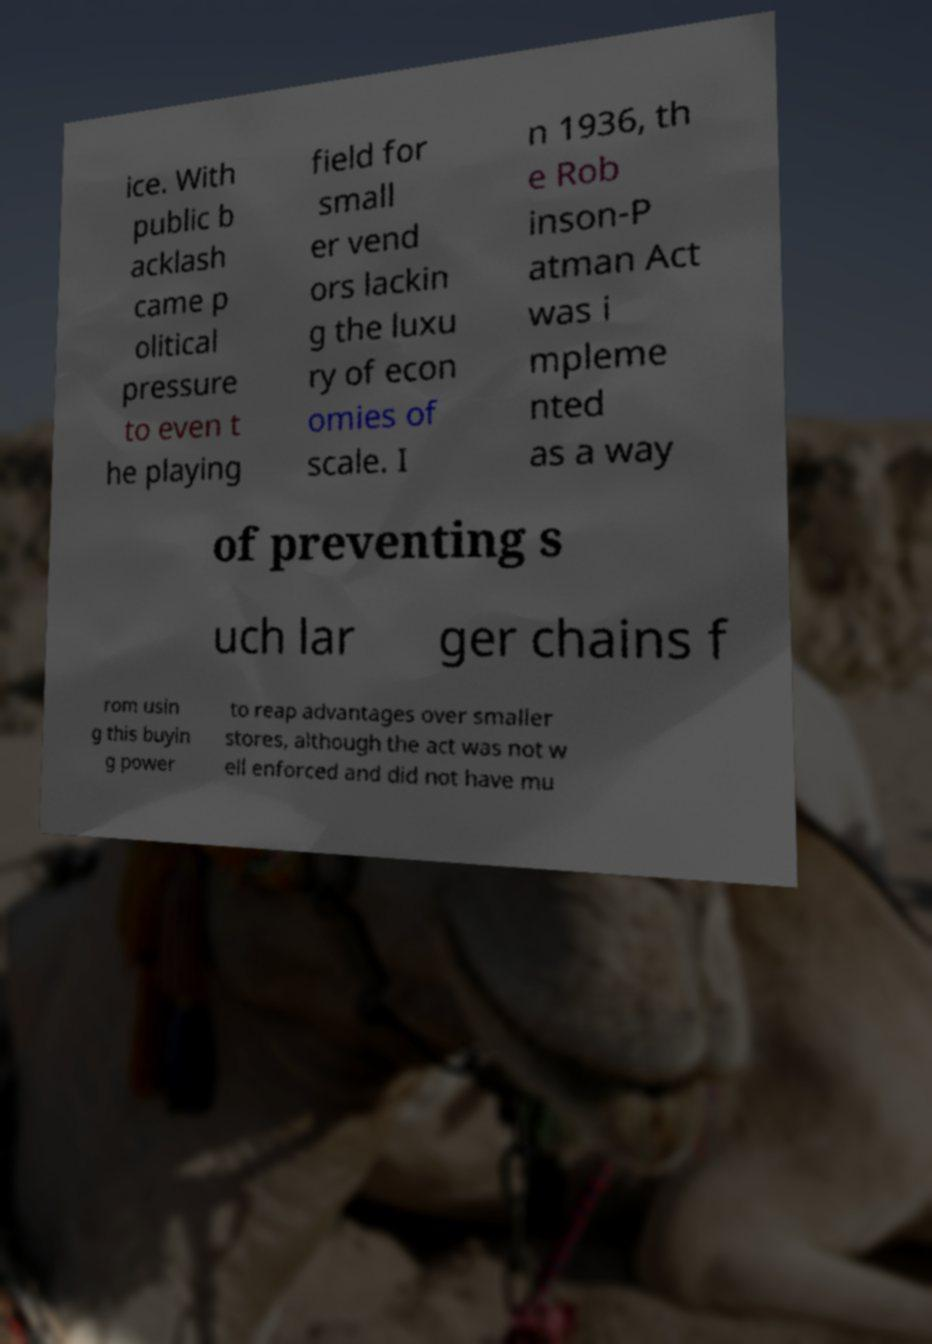I need the written content from this picture converted into text. Can you do that? ice. With public b acklash came p olitical pressure to even t he playing field for small er vend ors lackin g the luxu ry of econ omies of scale. I n 1936, th e Rob inson-P atman Act was i mpleme nted as a way of preventing s uch lar ger chains f rom usin g this buyin g power to reap advantages over smaller stores, although the act was not w ell enforced and did not have mu 